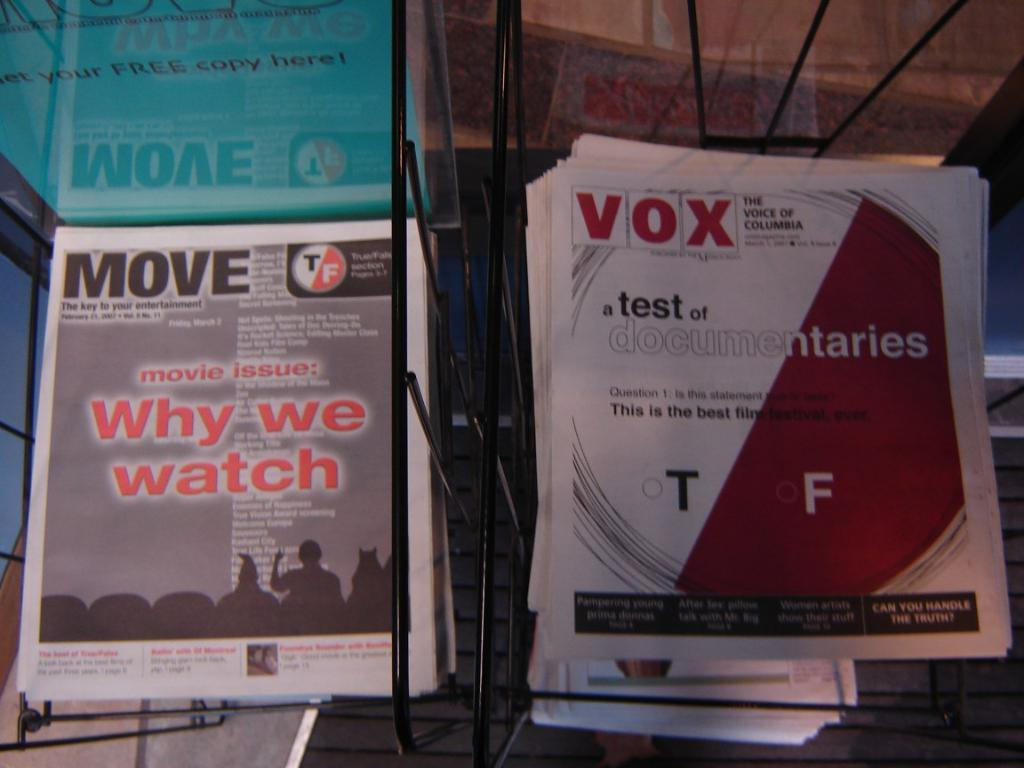<image>
Present a compact description of the photo's key features. Zines side by side; one is for VOX and another zine is called move 